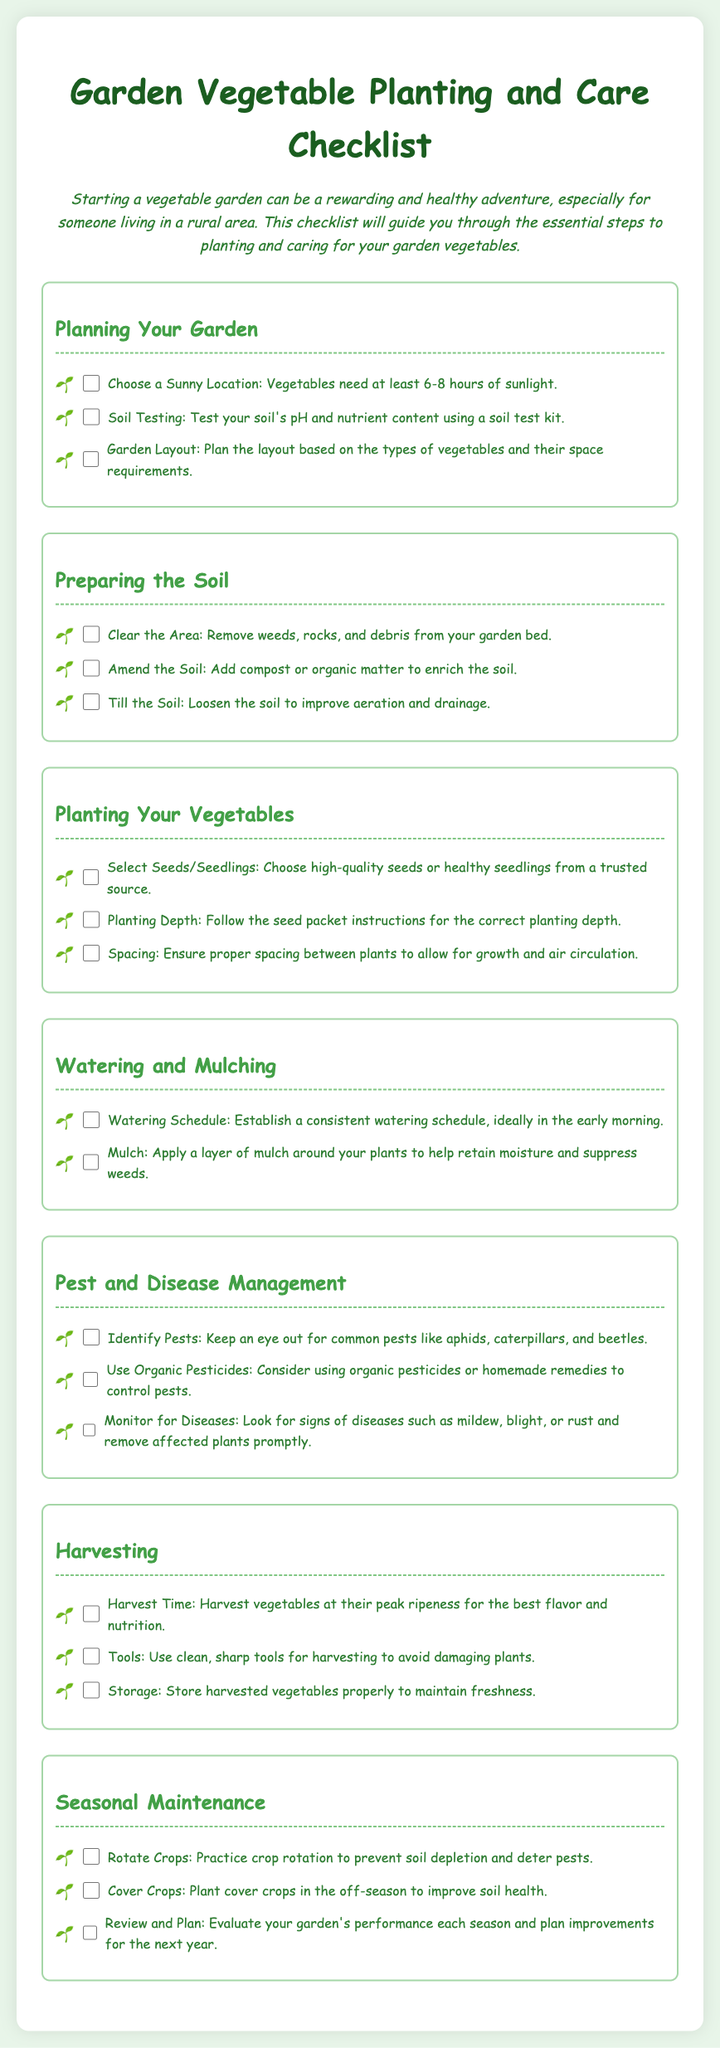What is the ideal amount of sunlight for vegetables? The document states that vegetables need at least 6-8 hours of sunlight.
Answer: 6-8 hours What should you use to test soil? According to the document, a soil test kit is recommended.
Answer: Soil test kit What is suggested to enrich the soil? The checklist suggests adding compost or organic matter.
Answer: Compost or organic matter What time of day is best for watering your garden? The document recommends establishing a watering schedule ideally in the early morning.
Answer: Early morning Which pests should you keep an eye out for? Common pests mentioned in the document include aphids, caterpillars, and beetles.
Answer: Aphids, caterpillars, and beetles What is a recommended method to control pests? The document suggests considering organic pesticides or homemade remedies.
Answer: Organic pesticides When should vegetables be harvested for the best flavor? The checklist advises to harvest vegetables at their peak ripeness.
Answer: Peak ripeness What practice helps prevent soil depletion? The document states that practicing crop rotation can help prevent soil depletion.
Answer: Crop rotation What should be done after harvesting vegetables? The checklist mentions that harvested vegetables should be stored properly to maintain freshness.
Answer: Stored properly 